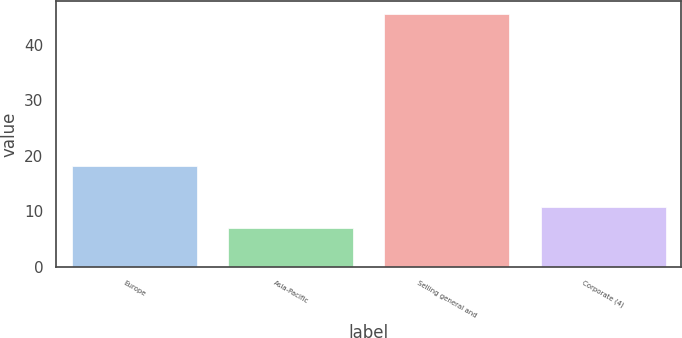Convert chart. <chart><loc_0><loc_0><loc_500><loc_500><bar_chart><fcel>Europe<fcel>Asia-Pacific<fcel>Selling general and<fcel>Corporate (4)<nl><fcel>18.1<fcel>6.9<fcel>45.6<fcel>10.77<nl></chart> 